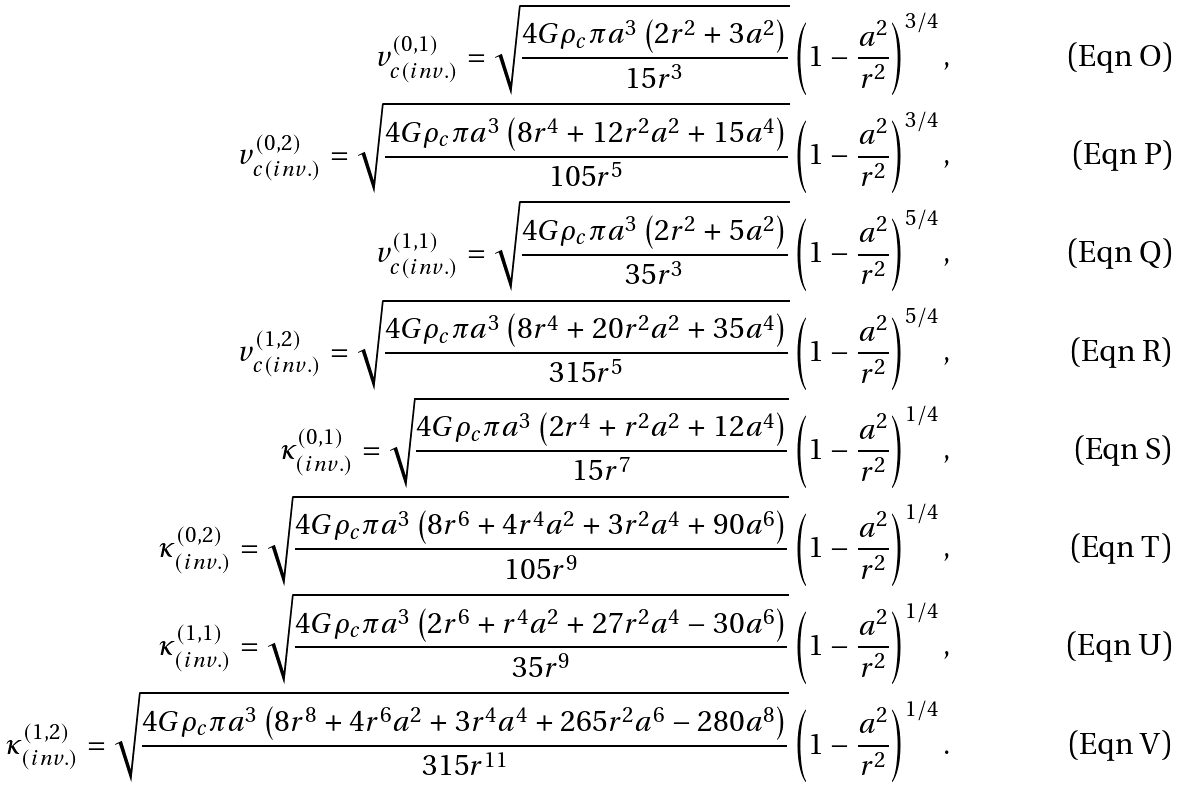<formula> <loc_0><loc_0><loc_500><loc_500>v _ { c ( i n v . ) } ^ { ( 0 , 1 ) } = \sqrt { \frac { 4 G \rho _ { c } \pi a ^ { 3 } \left ( 2 r ^ { 2 } + 3 a ^ { 2 } \right ) } { 1 5 r ^ { 3 } } } \left ( 1 - \frac { a ^ { 2 } } { r ^ { 2 } } \right ) ^ { 3 / 4 } , \\ v _ { c ( i n v . ) } ^ { ( 0 , 2 ) } = \sqrt { \frac { 4 G \rho _ { c } \pi a ^ { 3 } \left ( 8 r ^ { 4 } + 1 2 r ^ { 2 } a ^ { 2 } + 1 5 a ^ { 4 } \right ) } { 1 0 5 r ^ { 5 } } } \left ( 1 - \frac { a ^ { 2 } } { r ^ { 2 } } \right ) ^ { 3 / 4 } , \\ v _ { c ( i n v . ) } ^ { ( 1 , 1 ) } = \sqrt { \frac { 4 G \rho _ { c } \pi a ^ { 3 } \left ( 2 r ^ { 2 } + 5 a ^ { 2 } \right ) } { 3 5 r ^ { 3 } } } \left ( 1 - \frac { a ^ { 2 } } { r ^ { 2 } } \right ) ^ { 5 / 4 } , \\ v _ { c ( i n v . ) } ^ { ( 1 , 2 ) } = \sqrt { \frac { 4 G \rho _ { c } \pi a ^ { 3 } \left ( 8 r ^ { 4 } + 2 0 r ^ { 2 } a ^ { 2 } + 3 5 a ^ { 4 } \right ) } { 3 1 5 r ^ { 5 } } } \left ( 1 - \frac { a ^ { 2 } } { r ^ { 2 } } \right ) ^ { 5 / 4 } , \\ \kappa _ { ( i n v . ) } ^ { ( 0 , 1 ) } = \sqrt { \frac { 4 G \rho _ { c } \pi a ^ { 3 } \left ( 2 r ^ { 4 } + r ^ { 2 } a ^ { 2 } + 1 2 a ^ { 4 } \right ) } { 1 5 r ^ { 7 } } } \left ( 1 - \frac { a ^ { 2 } } { r ^ { 2 } } \right ) ^ { 1 / 4 } , \\ \kappa _ { ( i n v . ) } ^ { ( 0 , 2 ) } = \sqrt { \frac { 4 G \rho _ { c } \pi a ^ { 3 } \left ( 8 r ^ { 6 } + 4 r ^ { 4 } a ^ { 2 } + 3 r ^ { 2 } a ^ { 4 } + 9 0 a ^ { 6 } \right ) } { 1 0 5 r ^ { 9 } } } \left ( 1 - \frac { a ^ { 2 } } { r ^ { 2 } } \right ) ^ { 1 / 4 } , \\ \kappa _ { ( i n v . ) } ^ { ( 1 , 1 ) } = \sqrt { \frac { 4 G \rho _ { c } \pi a ^ { 3 } \left ( 2 r ^ { 6 } + r ^ { 4 } a ^ { 2 } + 2 7 r ^ { 2 } a ^ { 4 } - 3 0 a ^ { 6 } \right ) } { 3 5 r ^ { 9 } } } \left ( 1 - \frac { a ^ { 2 } } { r ^ { 2 } } \right ) ^ { 1 / 4 } , \\ \kappa _ { ( i n v . ) } ^ { ( 1 , 2 ) } = \sqrt { \frac { 4 G \rho _ { c } \pi a ^ { 3 } \left ( 8 r ^ { 8 } + 4 r ^ { 6 } a ^ { 2 } + 3 r ^ { 4 } a ^ { 4 } + 2 6 5 r ^ { 2 } a ^ { 6 } - 2 8 0 a ^ { 8 } \right ) } { 3 1 5 r ^ { 1 1 } } } \left ( 1 - \frac { a ^ { 2 } } { r ^ { 2 } } \right ) ^ { 1 / 4 } .</formula> 